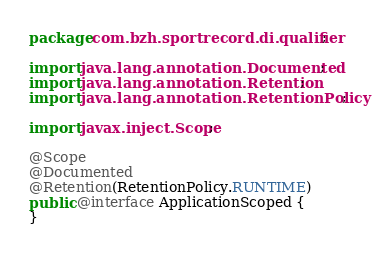<code> <loc_0><loc_0><loc_500><loc_500><_Java_>package com.bzh.sportrecord.di.qualifier;

import java.lang.annotation.Documented;
import java.lang.annotation.Retention;
import java.lang.annotation.RetentionPolicy;

import javax.inject.Scope;

@Scope
@Documented
@Retention(RetentionPolicy.RUNTIME)
public @interface ApplicationScoped {
}
</code> 